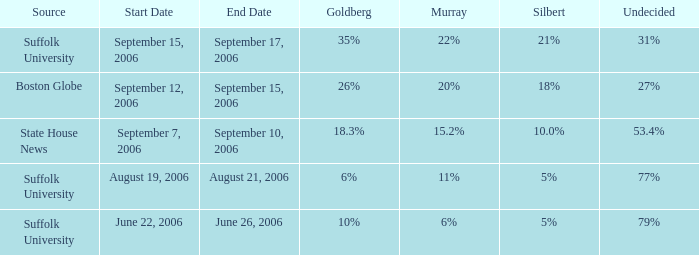What is the date of the poll where Murray had 11% from the Suffolk University source? August 19–21, 2006. 